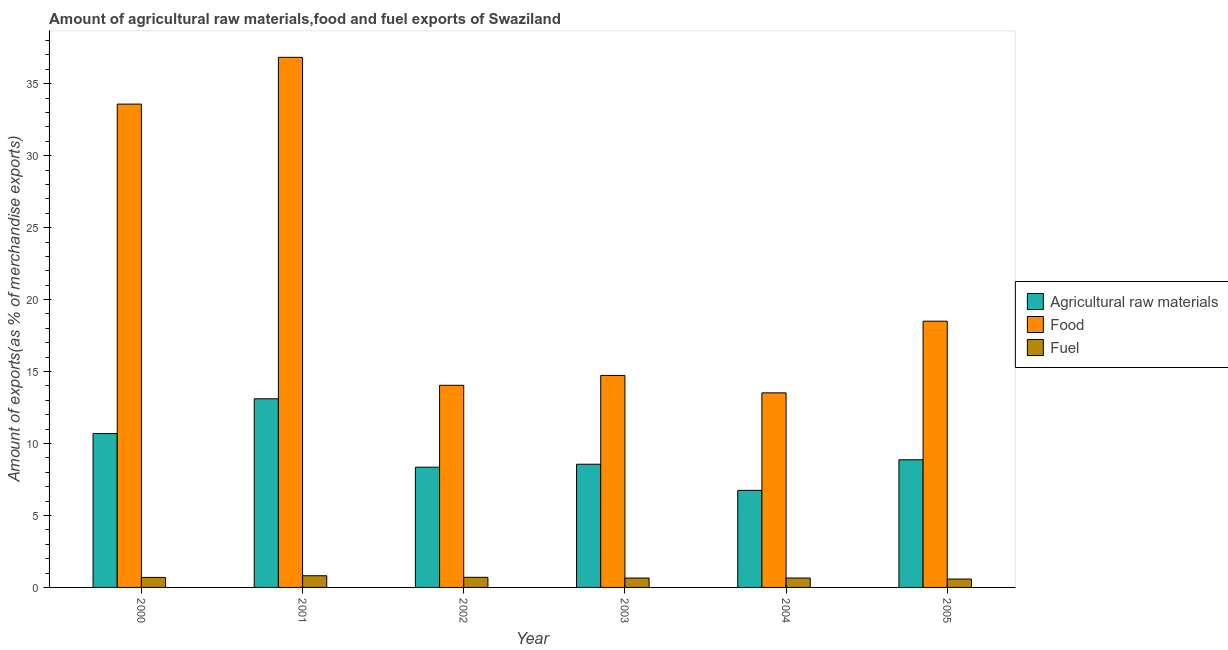Are the number of bars on each tick of the X-axis equal?
Keep it short and to the point. Yes. How many bars are there on the 5th tick from the left?
Give a very brief answer. 3. How many bars are there on the 1st tick from the right?
Your response must be concise. 3. In how many cases, is the number of bars for a given year not equal to the number of legend labels?
Your answer should be compact. 0. What is the percentage of raw materials exports in 2005?
Offer a very short reply. 8.87. Across all years, what is the maximum percentage of fuel exports?
Your answer should be very brief. 0.81. Across all years, what is the minimum percentage of food exports?
Offer a terse response. 13.52. In which year was the percentage of food exports maximum?
Give a very brief answer. 2001. What is the total percentage of fuel exports in the graph?
Provide a succinct answer. 4.1. What is the difference between the percentage of food exports in 2001 and that in 2003?
Your response must be concise. 22.1. What is the difference between the percentage of raw materials exports in 2001 and the percentage of fuel exports in 2004?
Your answer should be very brief. 6.36. What is the average percentage of food exports per year?
Your answer should be compact. 21.87. In the year 2004, what is the difference between the percentage of raw materials exports and percentage of food exports?
Keep it short and to the point. 0. What is the ratio of the percentage of food exports in 2000 to that in 2005?
Make the answer very short. 1.82. Is the difference between the percentage of fuel exports in 2001 and 2002 greater than the difference between the percentage of food exports in 2001 and 2002?
Keep it short and to the point. No. What is the difference between the highest and the second highest percentage of food exports?
Provide a short and direct response. 3.25. What is the difference between the highest and the lowest percentage of fuel exports?
Offer a very short reply. 0.23. In how many years, is the percentage of fuel exports greater than the average percentage of fuel exports taken over all years?
Provide a succinct answer. 3. What does the 1st bar from the left in 2003 represents?
Your response must be concise. Agricultural raw materials. What does the 3rd bar from the right in 2000 represents?
Your response must be concise. Agricultural raw materials. What is the difference between two consecutive major ticks on the Y-axis?
Provide a succinct answer. 5. Are the values on the major ticks of Y-axis written in scientific E-notation?
Offer a terse response. No. Does the graph contain any zero values?
Your answer should be very brief. No. Where does the legend appear in the graph?
Offer a terse response. Center right. How are the legend labels stacked?
Your answer should be compact. Vertical. What is the title of the graph?
Your answer should be very brief. Amount of agricultural raw materials,food and fuel exports of Swaziland. Does "Ages 15-20" appear as one of the legend labels in the graph?
Offer a terse response. No. What is the label or title of the X-axis?
Your answer should be very brief. Year. What is the label or title of the Y-axis?
Make the answer very short. Amount of exports(as % of merchandise exports). What is the Amount of exports(as % of merchandise exports) of Agricultural raw materials in 2000?
Give a very brief answer. 10.69. What is the Amount of exports(as % of merchandise exports) of Food in 2000?
Keep it short and to the point. 33.58. What is the Amount of exports(as % of merchandise exports) of Fuel in 2000?
Give a very brief answer. 0.7. What is the Amount of exports(as % of merchandise exports) of Agricultural raw materials in 2001?
Your answer should be compact. 13.11. What is the Amount of exports(as % of merchandise exports) of Food in 2001?
Keep it short and to the point. 36.83. What is the Amount of exports(as % of merchandise exports) of Fuel in 2001?
Your response must be concise. 0.81. What is the Amount of exports(as % of merchandise exports) in Agricultural raw materials in 2002?
Keep it short and to the point. 8.35. What is the Amount of exports(as % of merchandise exports) in Food in 2002?
Ensure brevity in your answer.  14.04. What is the Amount of exports(as % of merchandise exports) in Fuel in 2002?
Offer a very short reply. 0.7. What is the Amount of exports(as % of merchandise exports) in Agricultural raw materials in 2003?
Your response must be concise. 8.56. What is the Amount of exports(as % of merchandise exports) in Food in 2003?
Your answer should be very brief. 14.73. What is the Amount of exports(as % of merchandise exports) of Fuel in 2003?
Ensure brevity in your answer.  0.65. What is the Amount of exports(as % of merchandise exports) of Agricultural raw materials in 2004?
Your response must be concise. 6.74. What is the Amount of exports(as % of merchandise exports) in Food in 2004?
Make the answer very short. 13.52. What is the Amount of exports(as % of merchandise exports) in Fuel in 2004?
Keep it short and to the point. 0.65. What is the Amount of exports(as % of merchandise exports) of Agricultural raw materials in 2005?
Give a very brief answer. 8.87. What is the Amount of exports(as % of merchandise exports) in Food in 2005?
Provide a short and direct response. 18.5. What is the Amount of exports(as % of merchandise exports) in Fuel in 2005?
Your answer should be compact. 0.58. Across all years, what is the maximum Amount of exports(as % of merchandise exports) in Agricultural raw materials?
Make the answer very short. 13.11. Across all years, what is the maximum Amount of exports(as % of merchandise exports) in Food?
Your answer should be compact. 36.83. Across all years, what is the maximum Amount of exports(as % of merchandise exports) in Fuel?
Offer a terse response. 0.81. Across all years, what is the minimum Amount of exports(as % of merchandise exports) of Agricultural raw materials?
Provide a succinct answer. 6.74. Across all years, what is the minimum Amount of exports(as % of merchandise exports) in Food?
Your answer should be very brief. 13.52. Across all years, what is the minimum Amount of exports(as % of merchandise exports) in Fuel?
Your response must be concise. 0.58. What is the total Amount of exports(as % of merchandise exports) in Agricultural raw materials in the graph?
Make the answer very short. 56.32. What is the total Amount of exports(as % of merchandise exports) of Food in the graph?
Provide a short and direct response. 131.2. What is the total Amount of exports(as % of merchandise exports) of Fuel in the graph?
Offer a very short reply. 4.1. What is the difference between the Amount of exports(as % of merchandise exports) of Agricultural raw materials in 2000 and that in 2001?
Your answer should be very brief. -2.41. What is the difference between the Amount of exports(as % of merchandise exports) in Food in 2000 and that in 2001?
Ensure brevity in your answer.  -3.25. What is the difference between the Amount of exports(as % of merchandise exports) of Fuel in 2000 and that in 2001?
Keep it short and to the point. -0.12. What is the difference between the Amount of exports(as % of merchandise exports) in Agricultural raw materials in 2000 and that in 2002?
Your answer should be very brief. 2.34. What is the difference between the Amount of exports(as % of merchandise exports) of Food in 2000 and that in 2002?
Give a very brief answer. 19.54. What is the difference between the Amount of exports(as % of merchandise exports) of Fuel in 2000 and that in 2002?
Your answer should be compact. -0.01. What is the difference between the Amount of exports(as % of merchandise exports) of Agricultural raw materials in 2000 and that in 2003?
Ensure brevity in your answer.  2.13. What is the difference between the Amount of exports(as % of merchandise exports) in Food in 2000 and that in 2003?
Provide a short and direct response. 18.85. What is the difference between the Amount of exports(as % of merchandise exports) of Fuel in 2000 and that in 2003?
Ensure brevity in your answer.  0.04. What is the difference between the Amount of exports(as % of merchandise exports) in Agricultural raw materials in 2000 and that in 2004?
Offer a terse response. 3.95. What is the difference between the Amount of exports(as % of merchandise exports) in Food in 2000 and that in 2004?
Provide a short and direct response. 20.06. What is the difference between the Amount of exports(as % of merchandise exports) of Fuel in 2000 and that in 2004?
Provide a short and direct response. 0.04. What is the difference between the Amount of exports(as % of merchandise exports) of Agricultural raw materials in 2000 and that in 2005?
Offer a terse response. 1.82. What is the difference between the Amount of exports(as % of merchandise exports) in Food in 2000 and that in 2005?
Keep it short and to the point. 15.08. What is the difference between the Amount of exports(as % of merchandise exports) of Fuel in 2000 and that in 2005?
Provide a short and direct response. 0.11. What is the difference between the Amount of exports(as % of merchandise exports) of Agricultural raw materials in 2001 and that in 2002?
Ensure brevity in your answer.  4.75. What is the difference between the Amount of exports(as % of merchandise exports) of Food in 2001 and that in 2002?
Give a very brief answer. 22.79. What is the difference between the Amount of exports(as % of merchandise exports) in Fuel in 2001 and that in 2002?
Your answer should be compact. 0.11. What is the difference between the Amount of exports(as % of merchandise exports) in Agricultural raw materials in 2001 and that in 2003?
Your answer should be compact. 4.55. What is the difference between the Amount of exports(as % of merchandise exports) of Food in 2001 and that in 2003?
Keep it short and to the point. 22.1. What is the difference between the Amount of exports(as % of merchandise exports) in Fuel in 2001 and that in 2003?
Your answer should be compact. 0.16. What is the difference between the Amount of exports(as % of merchandise exports) in Agricultural raw materials in 2001 and that in 2004?
Offer a very short reply. 6.36. What is the difference between the Amount of exports(as % of merchandise exports) of Food in 2001 and that in 2004?
Make the answer very short. 23.31. What is the difference between the Amount of exports(as % of merchandise exports) in Fuel in 2001 and that in 2004?
Provide a succinct answer. 0.16. What is the difference between the Amount of exports(as % of merchandise exports) in Agricultural raw materials in 2001 and that in 2005?
Make the answer very short. 4.24. What is the difference between the Amount of exports(as % of merchandise exports) in Food in 2001 and that in 2005?
Keep it short and to the point. 18.33. What is the difference between the Amount of exports(as % of merchandise exports) in Fuel in 2001 and that in 2005?
Your response must be concise. 0.23. What is the difference between the Amount of exports(as % of merchandise exports) in Agricultural raw materials in 2002 and that in 2003?
Provide a short and direct response. -0.21. What is the difference between the Amount of exports(as % of merchandise exports) of Food in 2002 and that in 2003?
Provide a succinct answer. -0.69. What is the difference between the Amount of exports(as % of merchandise exports) in Fuel in 2002 and that in 2003?
Give a very brief answer. 0.05. What is the difference between the Amount of exports(as % of merchandise exports) in Agricultural raw materials in 2002 and that in 2004?
Give a very brief answer. 1.61. What is the difference between the Amount of exports(as % of merchandise exports) in Food in 2002 and that in 2004?
Your answer should be very brief. 0.52. What is the difference between the Amount of exports(as % of merchandise exports) of Fuel in 2002 and that in 2004?
Your response must be concise. 0.05. What is the difference between the Amount of exports(as % of merchandise exports) in Agricultural raw materials in 2002 and that in 2005?
Make the answer very short. -0.51. What is the difference between the Amount of exports(as % of merchandise exports) in Food in 2002 and that in 2005?
Offer a terse response. -4.46. What is the difference between the Amount of exports(as % of merchandise exports) of Fuel in 2002 and that in 2005?
Your answer should be compact. 0.12. What is the difference between the Amount of exports(as % of merchandise exports) in Agricultural raw materials in 2003 and that in 2004?
Provide a short and direct response. 1.82. What is the difference between the Amount of exports(as % of merchandise exports) in Food in 2003 and that in 2004?
Give a very brief answer. 1.21. What is the difference between the Amount of exports(as % of merchandise exports) in Fuel in 2003 and that in 2004?
Your response must be concise. -0. What is the difference between the Amount of exports(as % of merchandise exports) of Agricultural raw materials in 2003 and that in 2005?
Offer a very short reply. -0.31. What is the difference between the Amount of exports(as % of merchandise exports) of Food in 2003 and that in 2005?
Your answer should be very brief. -3.77. What is the difference between the Amount of exports(as % of merchandise exports) of Fuel in 2003 and that in 2005?
Offer a very short reply. 0.07. What is the difference between the Amount of exports(as % of merchandise exports) of Agricultural raw materials in 2004 and that in 2005?
Your answer should be very brief. -2.12. What is the difference between the Amount of exports(as % of merchandise exports) of Food in 2004 and that in 2005?
Make the answer very short. -4.98. What is the difference between the Amount of exports(as % of merchandise exports) of Fuel in 2004 and that in 2005?
Offer a terse response. 0.07. What is the difference between the Amount of exports(as % of merchandise exports) of Agricultural raw materials in 2000 and the Amount of exports(as % of merchandise exports) of Food in 2001?
Offer a terse response. -26.14. What is the difference between the Amount of exports(as % of merchandise exports) in Agricultural raw materials in 2000 and the Amount of exports(as % of merchandise exports) in Fuel in 2001?
Ensure brevity in your answer.  9.88. What is the difference between the Amount of exports(as % of merchandise exports) of Food in 2000 and the Amount of exports(as % of merchandise exports) of Fuel in 2001?
Make the answer very short. 32.77. What is the difference between the Amount of exports(as % of merchandise exports) in Agricultural raw materials in 2000 and the Amount of exports(as % of merchandise exports) in Food in 2002?
Give a very brief answer. -3.35. What is the difference between the Amount of exports(as % of merchandise exports) of Agricultural raw materials in 2000 and the Amount of exports(as % of merchandise exports) of Fuel in 2002?
Provide a short and direct response. 9.99. What is the difference between the Amount of exports(as % of merchandise exports) of Food in 2000 and the Amount of exports(as % of merchandise exports) of Fuel in 2002?
Provide a succinct answer. 32.88. What is the difference between the Amount of exports(as % of merchandise exports) of Agricultural raw materials in 2000 and the Amount of exports(as % of merchandise exports) of Food in 2003?
Provide a succinct answer. -4.04. What is the difference between the Amount of exports(as % of merchandise exports) of Agricultural raw materials in 2000 and the Amount of exports(as % of merchandise exports) of Fuel in 2003?
Give a very brief answer. 10.04. What is the difference between the Amount of exports(as % of merchandise exports) in Food in 2000 and the Amount of exports(as % of merchandise exports) in Fuel in 2003?
Give a very brief answer. 32.93. What is the difference between the Amount of exports(as % of merchandise exports) of Agricultural raw materials in 2000 and the Amount of exports(as % of merchandise exports) of Food in 2004?
Make the answer very short. -2.83. What is the difference between the Amount of exports(as % of merchandise exports) in Agricultural raw materials in 2000 and the Amount of exports(as % of merchandise exports) in Fuel in 2004?
Make the answer very short. 10.04. What is the difference between the Amount of exports(as % of merchandise exports) of Food in 2000 and the Amount of exports(as % of merchandise exports) of Fuel in 2004?
Make the answer very short. 32.93. What is the difference between the Amount of exports(as % of merchandise exports) of Agricultural raw materials in 2000 and the Amount of exports(as % of merchandise exports) of Food in 2005?
Keep it short and to the point. -7.81. What is the difference between the Amount of exports(as % of merchandise exports) of Agricultural raw materials in 2000 and the Amount of exports(as % of merchandise exports) of Fuel in 2005?
Offer a terse response. 10.11. What is the difference between the Amount of exports(as % of merchandise exports) in Food in 2000 and the Amount of exports(as % of merchandise exports) in Fuel in 2005?
Ensure brevity in your answer.  33. What is the difference between the Amount of exports(as % of merchandise exports) of Agricultural raw materials in 2001 and the Amount of exports(as % of merchandise exports) of Food in 2002?
Offer a terse response. -0.94. What is the difference between the Amount of exports(as % of merchandise exports) of Agricultural raw materials in 2001 and the Amount of exports(as % of merchandise exports) of Fuel in 2002?
Your answer should be compact. 12.4. What is the difference between the Amount of exports(as % of merchandise exports) in Food in 2001 and the Amount of exports(as % of merchandise exports) in Fuel in 2002?
Offer a very short reply. 36.13. What is the difference between the Amount of exports(as % of merchandise exports) in Agricultural raw materials in 2001 and the Amount of exports(as % of merchandise exports) in Food in 2003?
Make the answer very short. -1.62. What is the difference between the Amount of exports(as % of merchandise exports) of Agricultural raw materials in 2001 and the Amount of exports(as % of merchandise exports) of Fuel in 2003?
Your response must be concise. 12.45. What is the difference between the Amount of exports(as % of merchandise exports) in Food in 2001 and the Amount of exports(as % of merchandise exports) in Fuel in 2003?
Keep it short and to the point. 36.18. What is the difference between the Amount of exports(as % of merchandise exports) of Agricultural raw materials in 2001 and the Amount of exports(as % of merchandise exports) of Food in 2004?
Your answer should be compact. -0.41. What is the difference between the Amount of exports(as % of merchandise exports) of Agricultural raw materials in 2001 and the Amount of exports(as % of merchandise exports) of Fuel in 2004?
Offer a terse response. 12.45. What is the difference between the Amount of exports(as % of merchandise exports) in Food in 2001 and the Amount of exports(as % of merchandise exports) in Fuel in 2004?
Keep it short and to the point. 36.18. What is the difference between the Amount of exports(as % of merchandise exports) of Agricultural raw materials in 2001 and the Amount of exports(as % of merchandise exports) of Food in 2005?
Provide a succinct answer. -5.39. What is the difference between the Amount of exports(as % of merchandise exports) in Agricultural raw materials in 2001 and the Amount of exports(as % of merchandise exports) in Fuel in 2005?
Offer a very short reply. 12.52. What is the difference between the Amount of exports(as % of merchandise exports) in Food in 2001 and the Amount of exports(as % of merchandise exports) in Fuel in 2005?
Provide a succinct answer. 36.25. What is the difference between the Amount of exports(as % of merchandise exports) in Agricultural raw materials in 2002 and the Amount of exports(as % of merchandise exports) in Food in 2003?
Provide a short and direct response. -6.38. What is the difference between the Amount of exports(as % of merchandise exports) in Agricultural raw materials in 2002 and the Amount of exports(as % of merchandise exports) in Fuel in 2003?
Your answer should be very brief. 7.7. What is the difference between the Amount of exports(as % of merchandise exports) of Food in 2002 and the Amount of exports(as % of merchandise exports) of Fuel in 2003?
Provide a short and direct response. 13.39. What is the difference between the Amount of exports(as % of merchandise exports) of Agricultural raw materials in 2002 and the Amount of exports(as % of merchandise exports) of Food in 2004?
Give a very brief answer. -5.17. What is the difference between the Amount of exports(as % of merchandise exports) in Agricultural raw materials in 2002 and the Amount of exports(as % of merchandise exports) in Fuel in 2004?
Keep it short and to the point. 7.7. What is the difference between the Amount of exports(as % of merchandise exports) in Food in 2002 and the Amount of exports(as % of merchandise exports) in Fuel in 2004?
Give a very brief answer. 13.39. What is the difference between the Amount of exports(as % of merchandise exports) in Agricultural raw materials in 2002 and the Amount of exports(as % of merchandise exports) in Food in 2005?
Your response must be concise. -10.14. What is the difference between the Amount of exports(as % of merchandise exports) of Agricultural raw materials in 2002 and the Amount of exports(as % of merchandise exports) of Fuel in 2005?
Offer a terse response. 7.77. What is the difference between the Amount of exports(as % of merchandise exports) in Food in 2002 and the Amount of exports(as % of merchandise exports) in Fuel in 2005?
Make the answer very short. 13.46. What is the difference between the Amount of exports(as % of merchandise exports) of Agricultural raw materials in 2003 and the Amount of exports(as % of merchandise exports) of Food in 2004?
Your answer should be compact. -4.96. What is the difference between the Amount of exports(as % of merchandise exports) in Agricultural raw materials in 2003 and the Amount of exports(as % of merchandise exports) in Fuel in 2004?
Offer a very short reply. 7.91. What is the difference between the Amount of exports(as % of merchandise exports) of Food in 2003 and the Amount of exports(as % of merchandise exports) of Fuel in 2004?
Your answer should be compact. 14.08. What is the difference between the Amount of exports(as % of merchandise exports) in Agricultural raw materials in 2003 and the Amount of exports(as % of merchandise exports) in Food in 2005?
Offer a terse response. -9.94. What is the difference between the Amount of exports(as % of merchandise exports) in Agricultural raw materials in 2003 and the Amount of exports(as % of merchandise exports) in Fuel in 2005?
Give a very brief answer. 7.98. What is the difference between the Amount of exports(as % of merchandise exports) of Food in 2003 and the Amount of exports(as % of merchandise exports) of Fuel in 2005?
Provide a succinct answer. 14.15. What is the difference between the Amount of exports(as % of merchandise exports) of Agricultural raw materials in 2004 and the Amount of exports(as % of merchandise exports) of Food in 2005?
Offer a terse response. -11.75. What is the difference between the Amount of exports(as % of merchandise exports) in Agricultural raw materials in 2004 and the Amount of exports(as % of merchandise exports) in Fuel in 2005?
Keep it short and to the point. 6.16. What is the difference between the Amount of exports(as % of merchandise exports) in Food in 2004 and the Amount of exports(as % of merchandise exports) in Fuel in 2005?
Keep it short and to the point. 12.94. What is the average Amount of exports(as % of merchandise exports) in Agricultural raw materials per year?
Offer a very short reply. 9.39. What is the average Amount of exports(as % of merchandise exports) in Food per year?
Provide a succinct answer. 21.87. What is the average Amount of exports(as % of merchandise exports) of Fuel per year?
Your answer should be compact. 0.68. In the year 2000, what is the difference between the Amount of exports(as % of merchandise exports) in Agricultural raw materials and Amount of exports(as % of merchandise exports) in Food?
Make the answer very short. -22.89. In the year 2000, what is the difference between the Amount of exports(as % of merchandise exports) in Agricultural raw materials and Amount of exports(as % of merchandise exports) in Fuel?
Your answer should be compact. 9.99. In the year 2000, what is the difference between the Amount of exports(as % of merchandise exports) in Food and Amount of exports(as % of merchandise exports) in Fuel?
Make the answer very short. 32.89. In the year 2001, what is the difference between the Amount of exports(as % of merchandise exports) of Agricultural raw materials and Amount of exports(as % of merchandise exports) of Food?
Your answer should be compact. -23.72. In the year 2001, what is the difference between the Amount of exports(as % of merchandise exports) in Agricultural raw materials and Amount of exports(as % of merchandise exports) in Fuel?
Give a very brief answer. 12.29. In the year 2001, what is the difference between the Amount of exports(as % of merchandise exports) of Food and Amount of exports(as % of merchandise exports) of Fuel?
Ensure brevity in your answer.  36.02. In the year 2002, what is the difference between the Amount of exports(as % of merchandise exports) in Agricultural raw materials and Amount of exports(as % of merchandise exports) in Food?
Ensure brevity in your answer.  -5.69. In the year 2002, what is the difference between the Amount of exports(as % of merchandise exports) of Agricultural raw materials and Amount of exports(as % of merchandise exports) of Fuel?
Your response must be concise. 7.65. In the year 2002, what is the difference between the Amount of exports(as % of merchandise exports) of Food and Amount of exports(as % of merchandise exports) of Fuel?
Give a very brief answer. 13.34. In the year 2003, what is the difference between the Amount of exports(as % of merchandise exports) in Agricultural raw materials and Amount of exports(as % of merchandise exports) in Food?
Offer a very short reply. -6.17. In the year 2003, what is the difference between the Amount of exports(as % of merchandise exports) of Agricultural raw materials and Amount of exports(as % of merchandise exports) of Fuel?
Your response must be concise. 7.91. In the year 2003, what is the difference between the Amount of exports(as % of merchandise exports) of Food and Amount of exports(as % of merchandise exports) of Fuel?
Ensure brevity in your answer.  14.08. In the year 2004, what is the difference between the Amount of exports(as % of merchandise exports) of Agricultural raw materials and Amount of exports(as % of merchandise exports) of Food?
Give a very brief answer. -6.77. In the year 2004, what is the difference between the Amount of exports(as % of merchandise exports) in Agricultural raw materials and Amount of exports(as % of merchandise exports) in Fuel?
Keep it short and to the point. 6.09. In the year 2004, what is the difference between the Amount of exports(as % of merchandise exports) in Food and Amount of exports(as % of merchandise exports) in Fuel?
Provide a short and direct response. 12.87. In the year 2005, what is the difference between the Amount of exports(as % of merchandise exports) of Agricultural raw materials and Amount of exports(as % of merchandise exports) of Food?
Offer a terse response. -9.63. In the year 2005, what is the difference between the Amount of exports(as % of merchandise exports) in Agricultural raw materials and Amount of exports(as % of merchandise exports) in Fuel?
Provide a short and direct response. 8.29. In the year 2005, what is the difference between the Amount of exports(as % of merchandise exports) in Food and Amount of exports(as % of merchandise exports) in Fuel?
Your response must be concise. 17.92. What is the ratio of the Amount of exports(as % of merchandise exports) in Agricultural raw materials in 2000 to that in 2001?
Offer a very short reply. 0.82. What is the ratio of the Amount of exports(as % of merchandise exports) in Food in 2000 to that in 2001?
Ensure brevity in your answer.  0.91. What is the ratio of the Amount of exports(as % of merchandise exports) of Fuel in 2000 to that in 2001?
Provide a short and direct response. 0.86. What is the ratio of the Amount of exports(as % of merchandise exports) of Agricultural raw materials in 2000 to that in 2002?
Ensure brevity in your answer.  1.28. What is the ratio of the Amount of exports(as % of merchandise exports) of Food in 2000 to that in 2002?
Give a very brief answer. 2.39. What is the ratio of the Amount of exports(as % of merchandise exports) of Fuel in 2000 to that in 2002?
Offer a very short reply. 0.99. What is the ratio of the Amount of exports(as % of merchandise exports) in Agricultural raw materials in 2000 to that in 2003?
Give a very brief answer. 1.25. What is the ratio of the Amount of exports(as % of merchandise exports) in Food in 2000 to that in 2003?
Ensure brevity in your answer.  2.28. What is the ratio of the Amount of exports(as % of merchandise exports) in Fuel in 2000 to that in 2003?
Keep it short and to the point. 1.07. What is the ratio of the Amount of exports(as % of merchandise exports) of Agricultural raw materials in 2000 to that in 2004?
Your response must be concise. 1.59. What is the ratio of the Amount of exports(as % of merchandise exports) of Food in 2000 to that in 2004?
Ensure brevity in your answer.  2.48. What is the ratio of the Amount of exports(as % of merchandise exports) in Fuel in 2000 to that in 2004?
Provide a short and direct response. 1.07. What is the ratio of the Amount of exports(as % of merchandise exports) of Agricultural raw materials in 2000 to that in 2005?
Keep it short and to the point. 1.21. What is the ratio of the Amount of exports(as % of merchandise exports) in Food in 2000 to that in 2005?
Ensure brevity in your answer.  1.82. What is the ratio of the Amount of exports(as % of merchandise exports) of Fuel in 2000 to that in 2005?
Your answer should be very brief. 1.2. What is the ratio of the Amount of exports(as % of merchandise exports) of Agricultural raw materials in 2001 to that in 2002?
Your answer should be compact. 1.57. What is the ratio of the Amount of exports(as % of merchandise exports) in Food in 2001 to that in 2002?
Your answer should be compact. 2.62. What is the ratio of the Amount of exports(as % of merchandise exports) in Fuel in 2001 to that in 2002?
Ensure brevity in your answer.  1.16. What is the ratio of the Amount of exports(as % of merchandise exports) of Agricultural raw materials in 2001 to that in 2003?
Make the answer very short. 1.53. What is the ratio of the Amount of exports(as % of merchandise exports) of Food in 2001 to that in 2003?
Ensure brevity in your answer.  2.5. What is the ratio of the Amount of exports(as % of merchandise exports) in Fuel in 2001 to that in 2003?
Provide a succinct answer. 1.25. What is the ratio of the Amount of exports(as % of merchandise exports) in Agricultural raw materials in 2001 to that in 2004?
Your answer should be compact. 1.94. What is the ratio of the Amount of exports(as % of merchandise exports) of Food in 2001 to that in 2004?
Give a very brief answer. 2.72. What is the ratio of the Amount of exports(as % of merchandise exports) of Fuel in 2001 to that in 2004?
Your answer should be very brief. 1.24. What is the ratio of the Amount of exports(as % of merchandise exports) in Agricultural raw materials in 2001 to that in 2005?
Ensure brevity in your answer.  1.48. What is the ratio of the Amount of exports(as % of merchandise exports) of Food in 2001 to that in 2005?
Provide a short and direct response. 1.99. What is the ratio of the Amount of exports(as % of merchandise exports) of Fuel in 2001 to that in 2005?
Make the answer very short. 1.39. What is the ratio of the Amount of exports(as % of merchandise exports) of Agricultural raw materials in 2002 to that in 2003?
Your answer should be compact. 0.98. What is the ratio of the Amount of exports(as % of merchandise exports) in Food in 2002 to that in 2003?
Offer a very short reply. 0.95. What is the ratio of the Amount of exports(as % of merchandise exports) of Fuel in 2002 to that in 2003?
Your response must be concise. 1.08. What is the ratio of the Amount of exports(as % of merchandise exports) in Agricultural raw materials in 2002 to that in 2004?
Provide a succinct answer. 1.24. What is the ratio of the Amount of exports(as % of merchandise exports) of Food in 2002 to that in 2004?
Make the answer very short. 1.04. What is the ratio of the Amount of exports(as % of merchandise exports) in Fuel in 2002 to that in 2004?
Your response must be concise. 1.08. What is the ratio of the Amount of exports(as % of merchandise exports) of Agricultural raw materials in 2002 to that in 2005?
Make the answer very short. 0.94. What is the ratio of the Amount of exports(as % of merchandise exports) in Food in 2002 to that in 2005?
Provide a short and direct response. 0.76. What is the ratio of the Amount of exports(as % of merchandise exports) of Fuel in 2002 to that in 2005?
Keep it short and to the point. 1.21. What is the ratio of the Amount of exports(as % of merchandise exports) of Agricultural raw materials in 2003 to that in 2004?
Your answer should be compact. 1.27. What is the ratio of the Amount of exports(as % of merchandise exports) of Food in 2003 to that in 2004?
Make the answer very short. 1.09. What is the ratio of the Amount of exports(as % of merchandise exports) of Fuel in 2003 to that in 2004?
Offer a very short reply. 1. What is the ratio of the Amount of exports(as % of merchandise exports) in Agricultural raw materials in 2003 to that in 2005?
Keep it short and to the point. 0.97. What is the ratio of the Amount of exports(as % of merchandise exports) in Food in 2003 to that in 2005?
Your response must be concise. 0.8. What is the ratio of the Amount of exports(as % of merchandise exports) in Fuel in 2003 to that in 2005?
Offer a terse response. 1.12. What is the ratio of the Amount of exports(as % of merchandise exports) in Agricultural raw materials in 2004 to that in 2005?
Offer a terse response. 0.76. What is the ratio of the Amount of exports(as % of merchandise exports) of Food in 2004 to that in 2005?
Your response must be concise. 0.73. What is the ratio of the Amount of exports(as % of merchandise exports) of Fuel in 2004 to that in 2005?
Your answer should be compact. 1.12. What is the difference between the highest and the second highest Amount of exports(as % of merchandise exports) of Agricultural raw materials?
Your response must be concise. 2.41. What is the difference between the highest and the second highest Amount of exports(as % of merchandise exports) in Food?
Make the answer very short. 3.25. What is the difference between the highest and the second highest Amount of exports(as % of merchandise exports) of Fuel?
Give a very brief answer. 0.11. What is the difference between the highest and the lowest Amount of exports(as % of merchandise exports) in Agricultural raw materials?
Give a very brief answer. 6.36. What is the difference between the highest and the lowest Amount of exports(as % of merchandise exports) in Food?
Make the answer very short. 23.31. What is the difference between the highest and the lowest Amount of exports(as % of merchandise exports) of Fuel?
Make the answer very short. 0.23. 